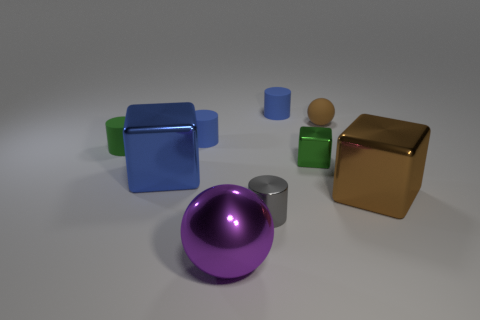Subtract all yellow cylinders. Subtract all green cubes. How many cylinders are left? 4 Add 1 red matte spheres. How many objects exist? 10 Subtract all cylinders. How many objects are left? 5 Add 8 green balls. How many green balls exist? 8 Subtract 0 red spheres. How many objects are left? 9 Subtract all matte objects. Subtract all big metal cubes. How many objects are left? 3 Add 5 balls. How many balls are left? 7 